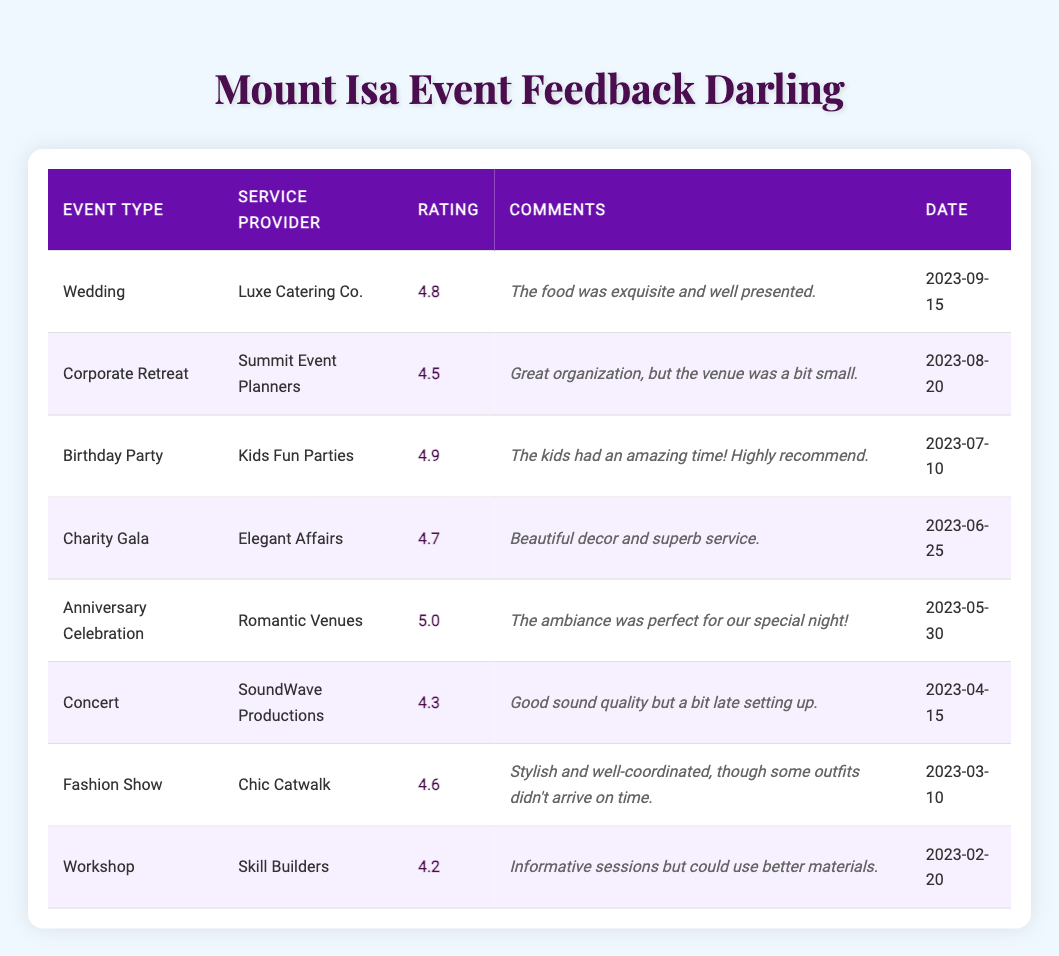What is the highest client rating? From the table, the highest rating is 5.0 given for the Anniversary Celebration by Romantic Venues.
Answer: 5.0 Which service provider received the lowest rating? Looking at the ratings, the provider with the lowest rating is Skill Builders, with a rating of 4.2 for their Workshop.
Answer: Skill Builders What event type received a rating of 4.9? The Birthday Party received a rating of 4.9 according to the data in the table.
Answer: Birthday Party How many events received a rating of 4.5 or above? By counting the ratings of 4.5 or higher (4.8, 4.5, 4.9, 4.7, 5.0, 4.3, 4.6), there are 6 events that meet this criteria.
Answer: 6 What is the average rating of all events? To calculate the average, sum all the ratings: (4.8 + 4.5 + 4.9 + 4.7 + 5.0 + 4.3 + 4.6 + 4.2) = 36.0 and then divide by 8 (the number of events). Thus, the average is 36.0 / 8 = 4.5.
Answer: 4.5 Did the Luxury Catering Co. receive a higher rating than 4.6? The rating for Luxe Catering Co. is 4.8, which is higher than 4.6. Therefore, the answer is yes.
Answer: Yes Which event type had the best comments? The Anniversary Celebration received the best comments, stating that "The ambiance was perfect for our special night," which indicates a very positive sentiment.
Answer: Anniversary Celebration Was there any event that received a rating of 4.2? Yes, according to the table, the Workshop had a rating of 4.2.
Answer: Yes Which event had the earliest date? The Workshop held on February 20, 2023, is the earliest event listed in the table.
Answer: Workshop How many events were held in Mount Isa? All events listed in the table are located in Mount Isa, making a total of 8 events.
Answer: 8 What is the difference between the highest and lowest rating? The highest rating is 5.0 and the lowest is 4.2. The difference is 5.0 - 4.2 = 0.8.
Answer: 0.8 